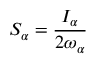<formula> <loc_0><loc_0><loc_500><loc_500>S _ { \alpha } = \frac { I _ { \alpha } } { 2 \omega _ { \alpha } }</formula> 